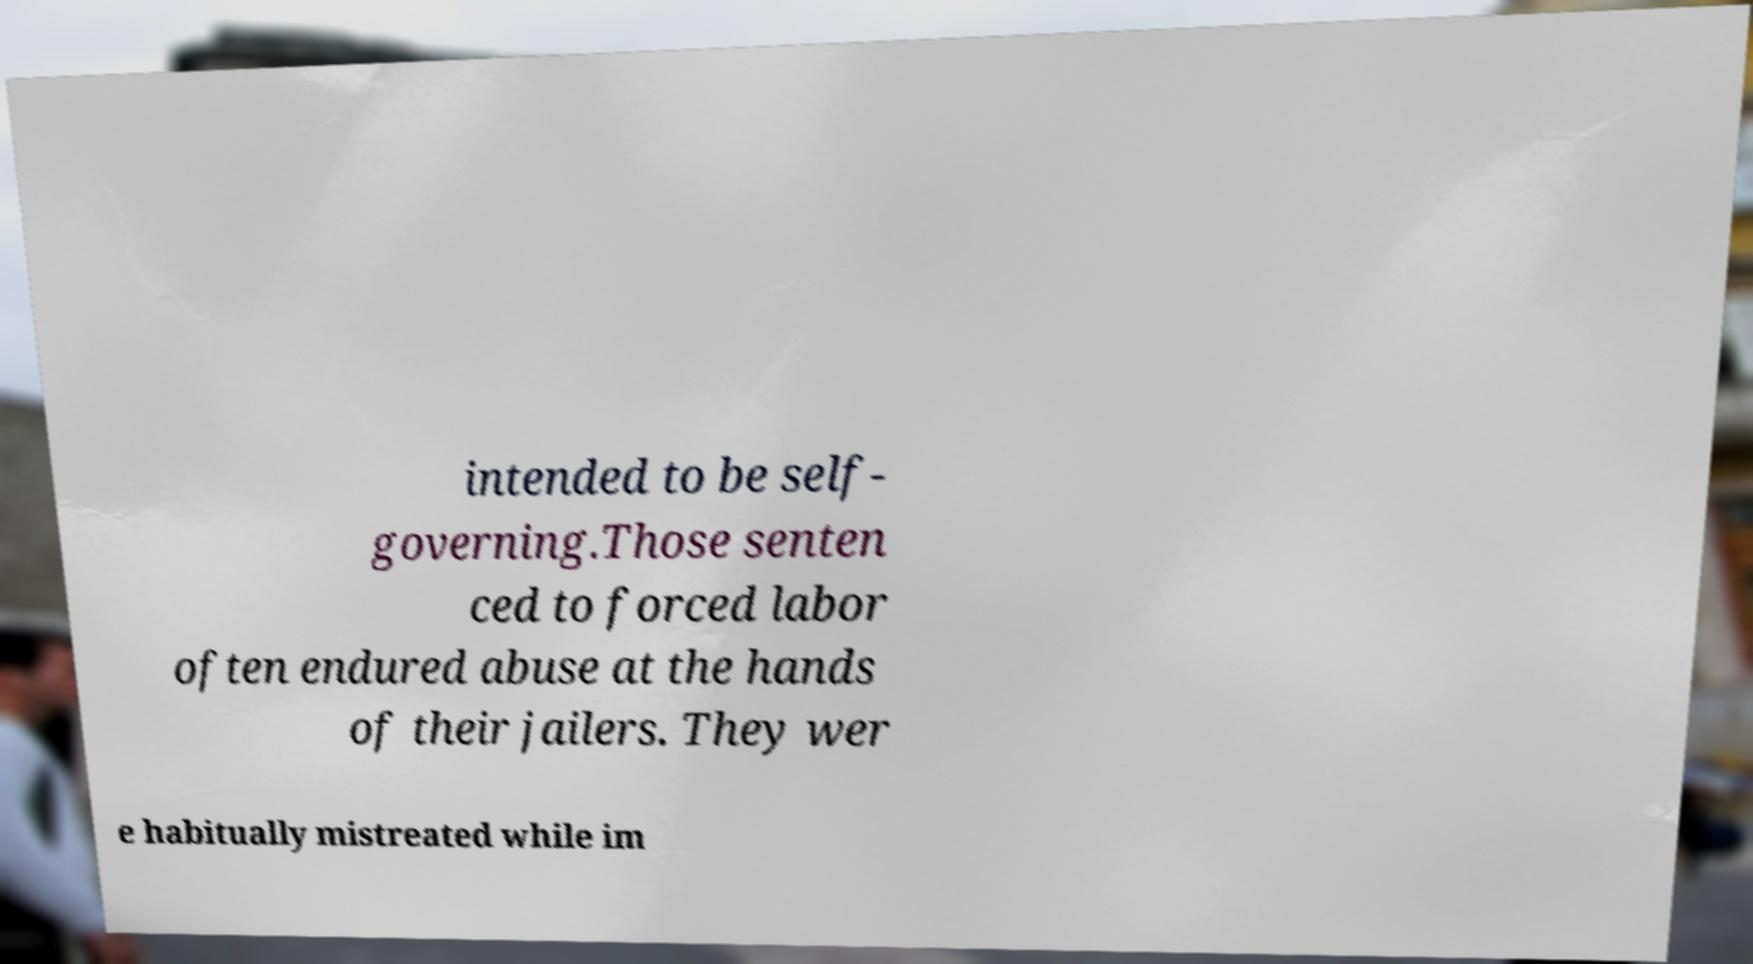Can you read and provide the text displayed in the image?This photo seems to have some interesting text. Can you extract and type it out for me? intended to be self- governing.Those senten ced to forced labor often endured abuse at the hands of their jailers. They wer e habitually mistreated while im 